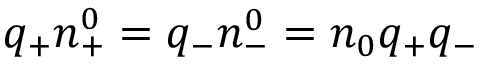Convert formula to latex. <formula><loc_0><loc_0><loc_500><loc_500>q _ { + } n _ { + } ^ { 0 } = q _ { - } n _ { - } ^ { 0 } = n _ { 0 } q _ { + } q _ { - }</formula> 